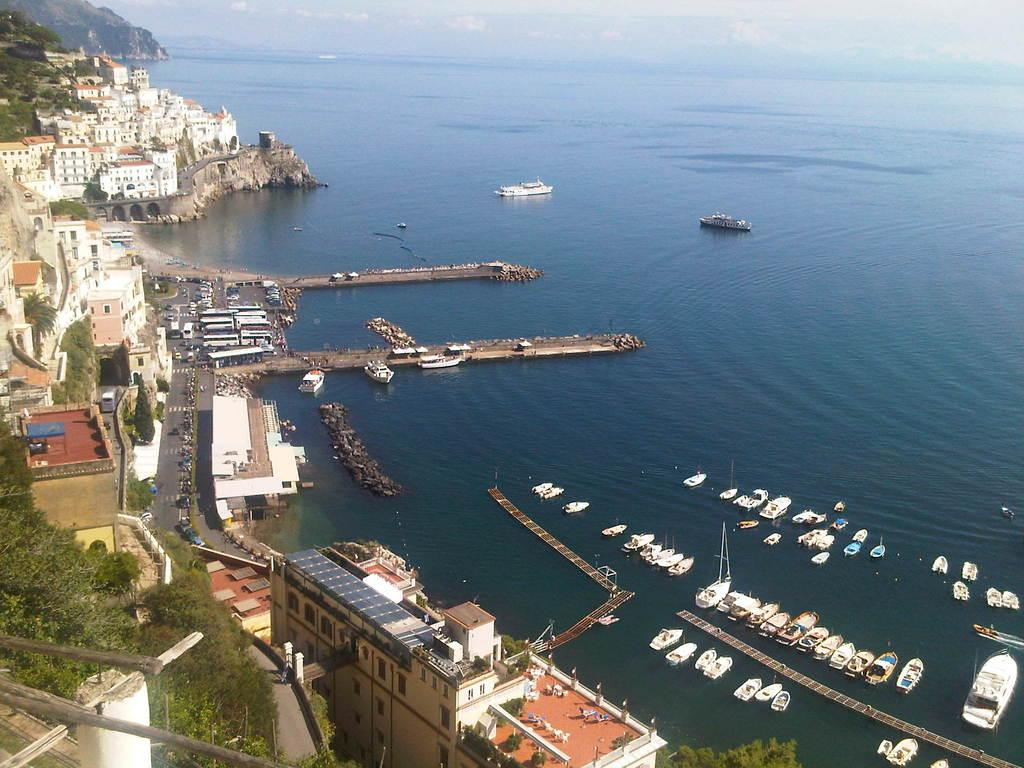What can be seen in the right corner of the image? There are boats on the water in the right corner of the image. What is located in the left corner of the image? There are buildings, trees, and vehicles in the left corner of the image. What type of pets can be seen learning a new patch in the image? There are no pets or patches present in the image. What type of learning activity is taking place in the image? There is no learning activity depicted in the image; it features boats, buildings, trees, and vehicles. 